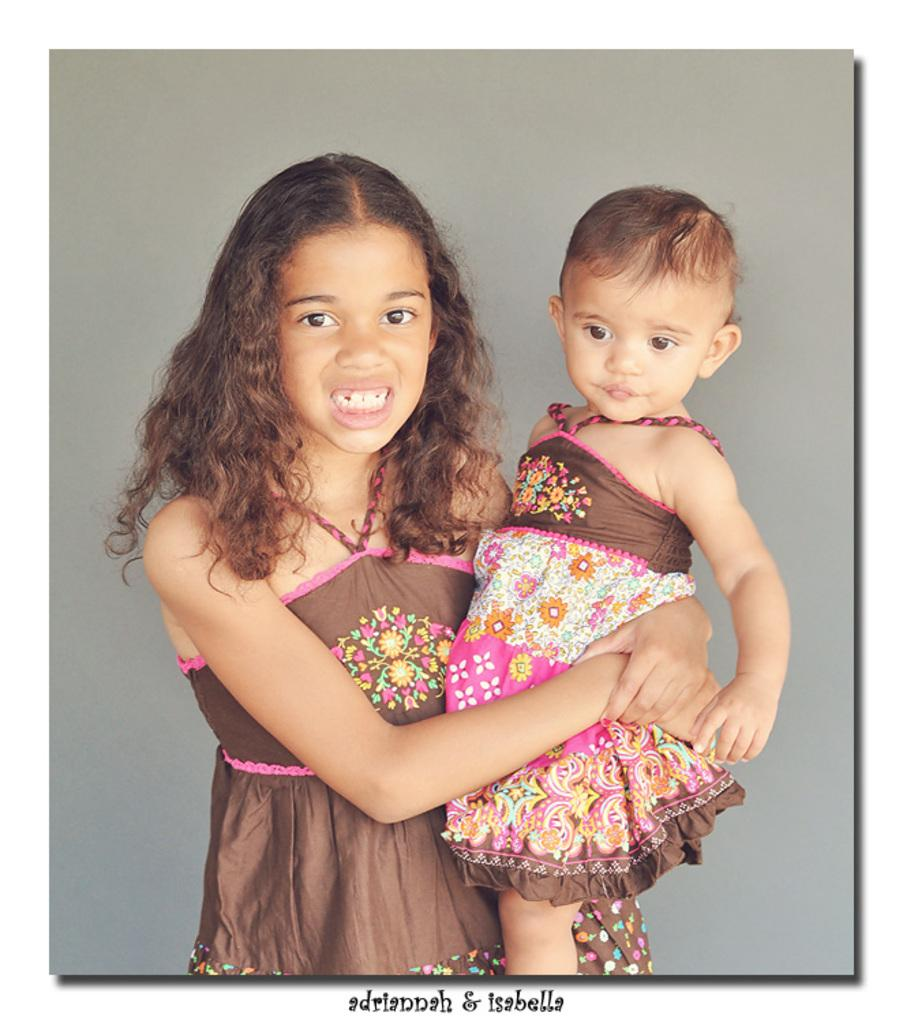Who is the main subject in the image? There is a girl in the image. What is the girl doing in the image? The girl is standing. Can you describe what the girl is holding in the image? The girl is holding a small baby girl. What does the image smell like? The image does not have a smell, as it is a visual representation. 